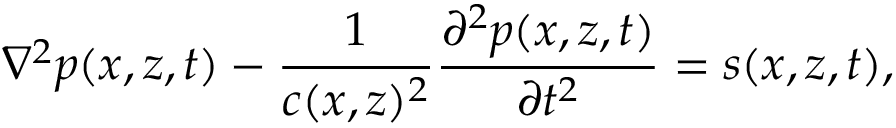<formula> <loc_0><loc_0><loc_500><loc_500>\nabla ^ { 2 } p ( x , z , t ) - \frac { 1 } { c ( x , z ) ^ { 2 } } \frac { \partial ^ { 2 } p ( x , z , t ) } { \partial t ^ { 2 } } = s ( x , z , t ) ,</formula> 